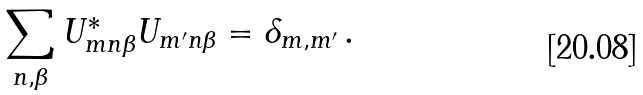<formula> <loc_0><loc_0><loc_500><loc_500>\sum _ { n , \beta } U _ { m n \beta } ^ { * } U _ { m ^ { \prime } n \beta } = \delta _ { m , m ^ { \prime } } \, .</formula> 